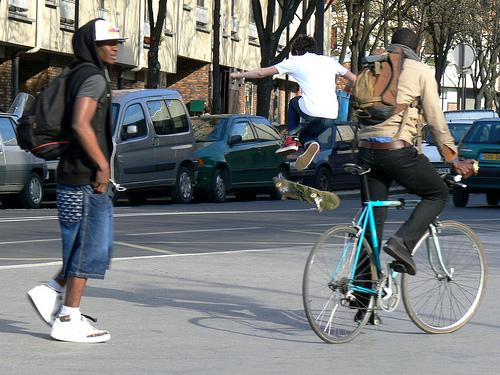Estimate the image's overall quality based on the clarity of objects and details. High quality, objects are clearly visible and well-detailed. In a few words, describe the atmosphere or sentiment of the image. Energetic, busy and dynamic street life. What is the overall scene depicted in the image? A busy street scene with men on bikes and skateboards, cars parked on the side of the road, and buildings nearby. What role do the two guys traveling together play in the image? They add a sense of camaraderie and shared adventure to the scene. Identify the two means of transportation used by individuals in the image. A skateboard and a bicycle. Explain the interaction between the man in mid air and the skateboard in mid air. The man in mid air seems to be performing a trick on the skateboard, as both are suspended above the ground. How many objects or subjects in the image are involved in a complex reasoning task, like performing a trick or action that requires skill? Two: the man on the skateboard and the man on the bike. Mention the color and attributes of the road in the image. The road is grey marked tarmac with noticeable traffic lines. How many big black tree stems are present in the image? Six. Does the image contain more trees or parked cars?  Trees In a poetic style, describe the main action taking place in the image. Amidst the urban jungle's embrace, warriors take flight, their steeds of bicycles and skateboards to conquer the paved terrain. Which element of the car is visible in the image? License plate What are the immediate surroundings of the grey marked tarmac road? Big black tree stems, buildings, men, bike, and skateboard Are there any bikes in the image? If so, how many? Yes, 1 bike List every object on or above the road. Men, cars, bicycle, skateboard, buildings, and big black tree stems Who has a larger backpack? The man carrying a large backpack Identify objects surrounding the parked cars. Buildings and big black tree stems Identify the events occurring in the image.  Men riding a bicycle and a skateboard on the street What are the modes of transport of the traveling men? Bicycle and skateboard What color are the tree stems in the image? Big black Create a story using the traveling men as your characters, and briefly describe their journey. Once upon a time, two friends embarked on an adventure across the bustling city. One rode his trusty bicycle, while the other expertly glided on his skateboard. Together they faced challenges, navigated busy streets, and witnessed the towering landscapes of their urban world. What type of road is depicted in the image? Tarmac road What scenario do the large backpacks and various mode of transport suggest? Traveling or adventure Write a creative title for the image while capturing the main actions. "Cities in Motion: Adventurers on Wheels" For the following options, choose the one that best describes the main subjects of the image: A) People driving cars B) Animals in the wild C) Men with various modes of transport on the road D) Children playing in a park C) Men with various modes of transport on the road What is the activity performed by the man in mid-air? Skateboarding What type of objects can you see in the air in the image? A man and a skateboard List the objects that the men on the street are carrying. Large backpack, bicycle, and skateboard 